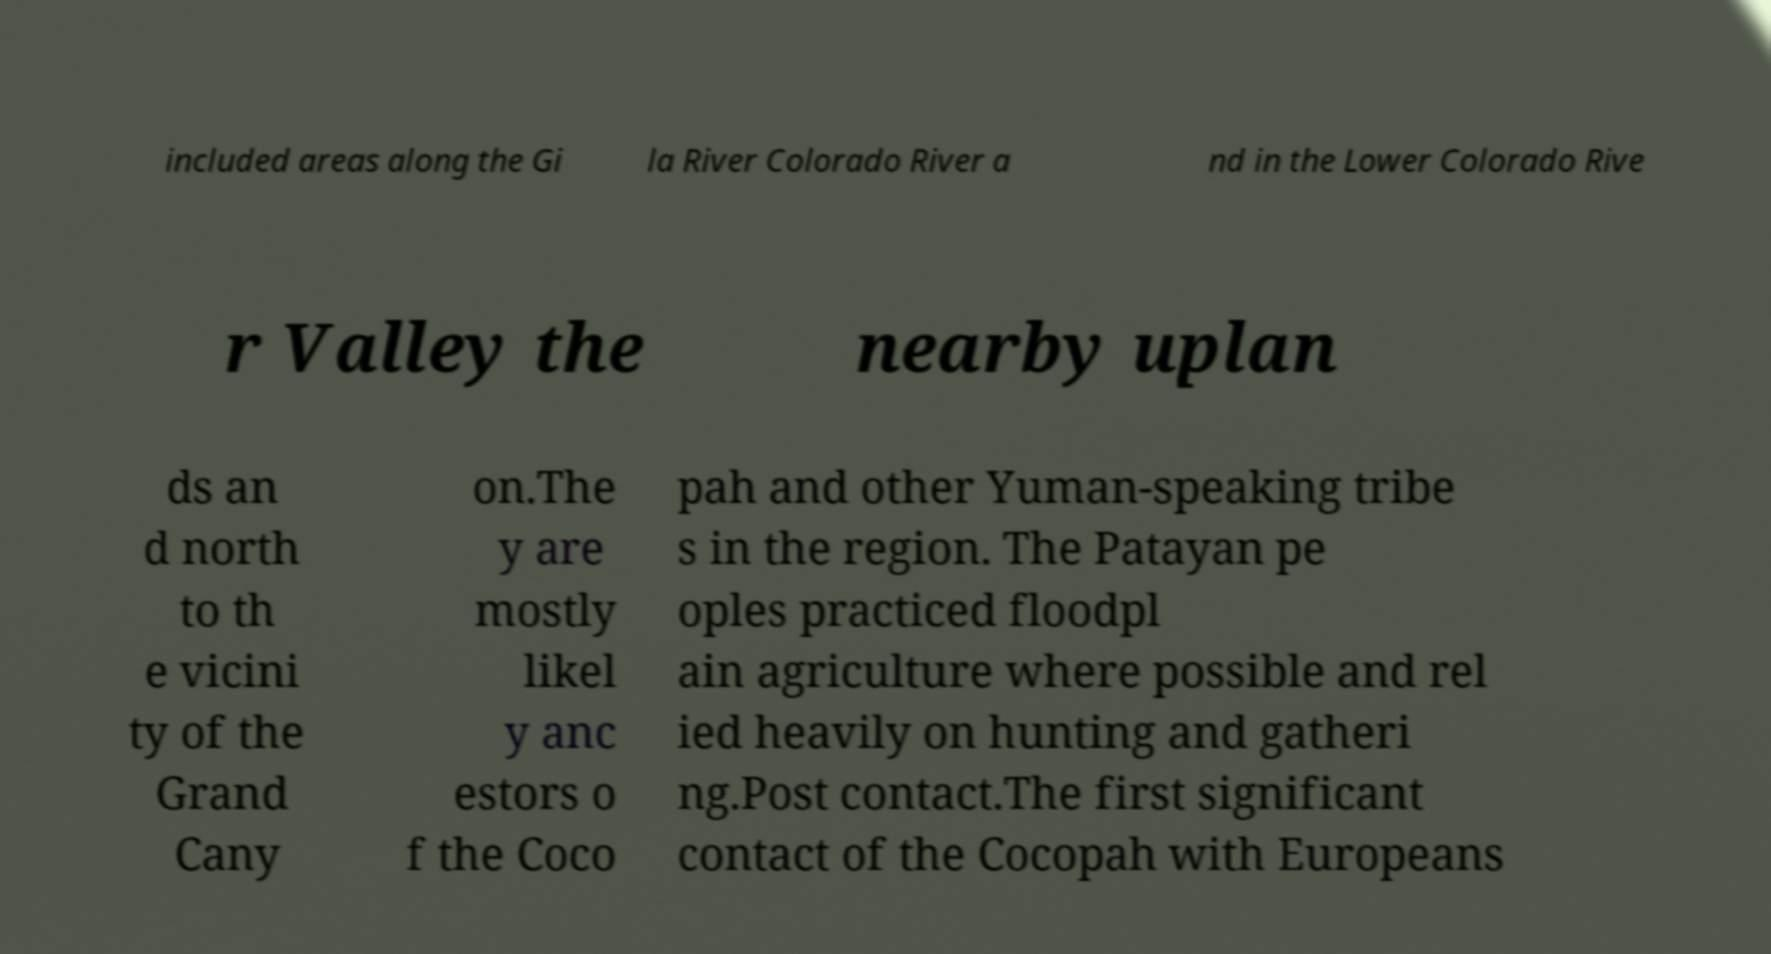Could you extract and type out the text from this image? included areas along the Gi la River Colorado River a nd in the Lower Colorado Rive r Valley the nearby uplan ds an d north to th e vicini ty of the Grand Cany on.The y are mostly likel y anc estors o f the Coco pah and other Yuman-speaking tribe s in the region. The Patayan pe oples practiced floodpl ain agriculture where possible and rel ied heavily on hunting and gatheri ng.Post contact.The first significant contact of the Cocopah with Europeans 